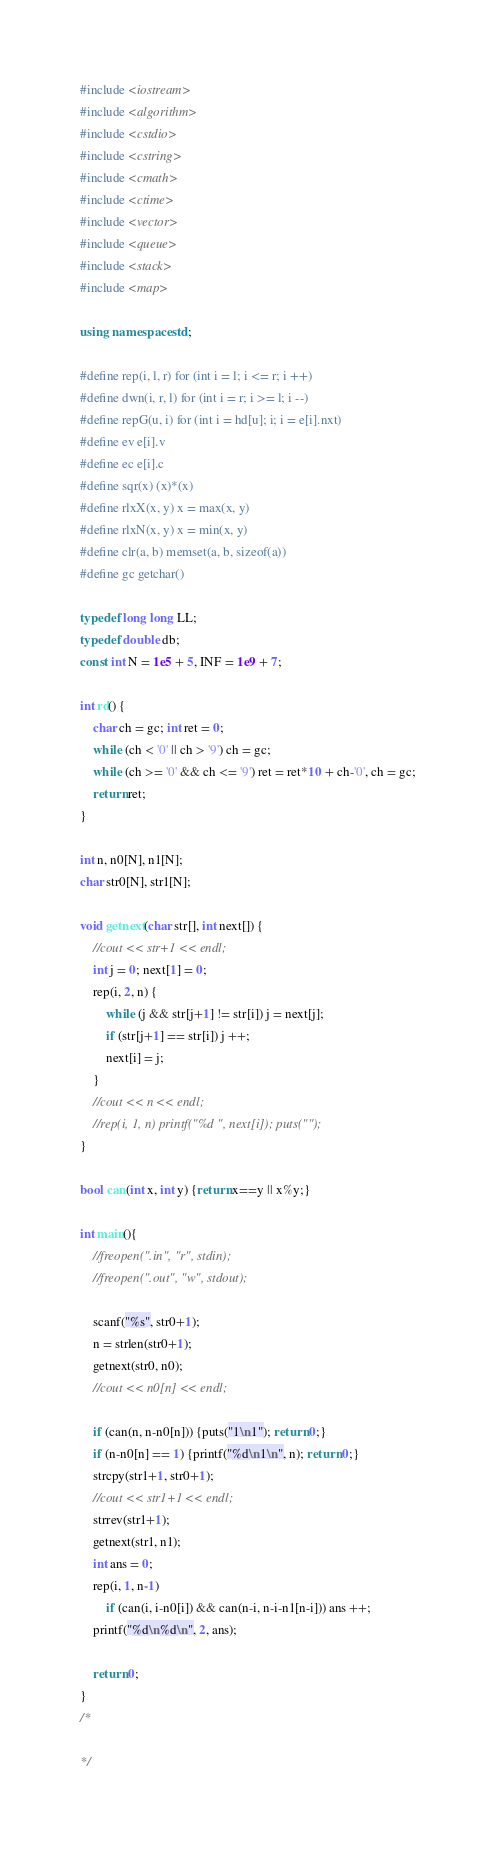Convert code to text. <code><loc_0><loc_0><loc_500><loc_500><_C++_>#include <iostream>
#include <algorithm>
#include <cstdio>
#include <cstring>
#include <cmath>
#include <ctime>
#include <vector>
#include <queue>
#include <stack>
#include <map>

using namespace std;

#define rep(i, l, r) for (int i = l; i <= r; i ++)
#define dwn(i, r, l) for (int i = r; i >= l; i --)
#define repG(u, i) for (int i = hd[u]; i; i = e[i].nxt)
#define ev e[i].v
#define ec e[i].c
#define sqr(x) (x)*(x)
#define rlxX(x, y) x = max(x, y)
#define rlxN(x, y) x = min(x, y)
#define clr(a, b) memset(a, b, sizeof(a))
#define gc getchar()

typedef long long LL;
typedef double db;
const int N = 1e5 + 5, INF = 1e9 + 7;

int rd() {
	char ch = gc; int ret = 0;
	while (ch < '0' || ch > '9') ch = gc;
	while (ch >= '0' && ch <= '9') ret = ret*10 + ch-'0', ch = gc;
	return ret;
}

int n, n0[N], n1[N];
char str0[N], str1[N];

void getnext(char str[], int next[]) {
	//cout << str+1 << endl;
	int j = 0; next[1] = 0;
	rep(i, 2, n) {
		while (j && str[j+1] != str[i]) j = next[j];
		if (str[j+1] == str[i]) j ++;
		next[i] = j;
	}
	//cout << n << endl;
	//rep(i, 1, n) printf("%d ", next[i]); puts("");
}

bool can(int x, int y) {return x==y || x%y;}

int main(){
	//freopen(".in", "r", stdin);
	//freopen(".out", "w", stdout);

	scanf("%s", str0+1);
	n = strlen(str0+1);
	getnext(str0, n0);
	//cout << n0[n] << endl;

	if (can(n, n-n0[n])) {puts("1\n1"); return 0;}
	if (n-n0[n] == 1) {printf("%d\n1\n", n); return 0;}
	strcpy(str1+1, str0+1);
	//cout << str1+1 << endl;
	strrev(str1+1);
	getnext(str1, n1);
	int ans = 0;
	rep(i, 1, n-1) 
		if (can(i, i-n0[i]) && can(n-i, n-i-n1[n-i])) ans ++;
	printf("%d\n%d\n", 2, ans);
	
	return 0;
}
/*

*/

</code> 